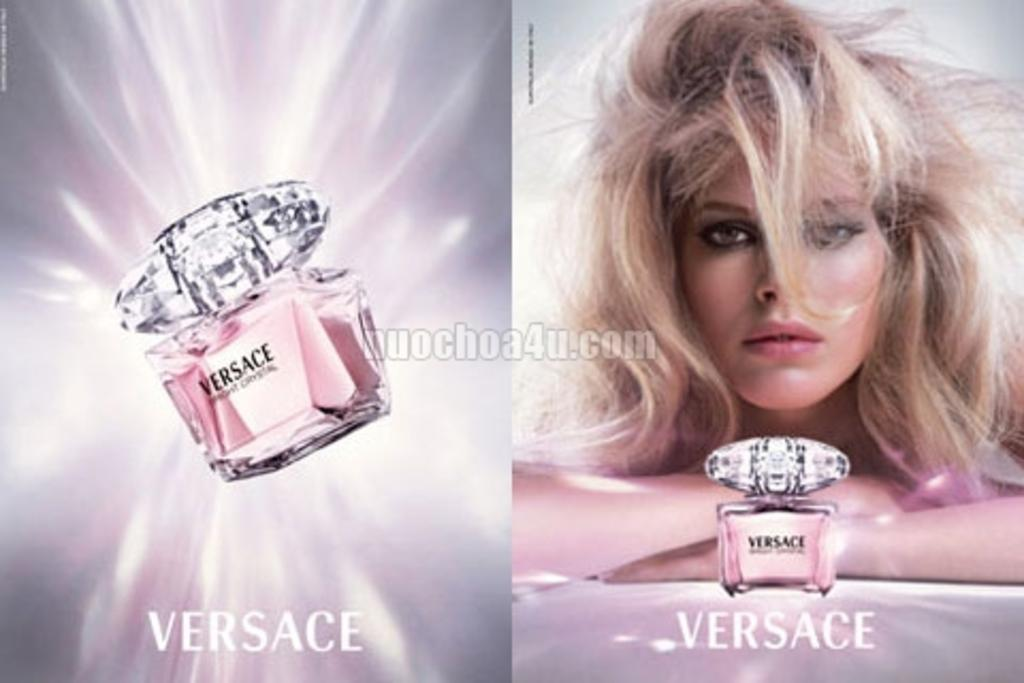<image>
Write a terse but informative summary of the picture. An ad for a pink bottle of Versace perfume. 